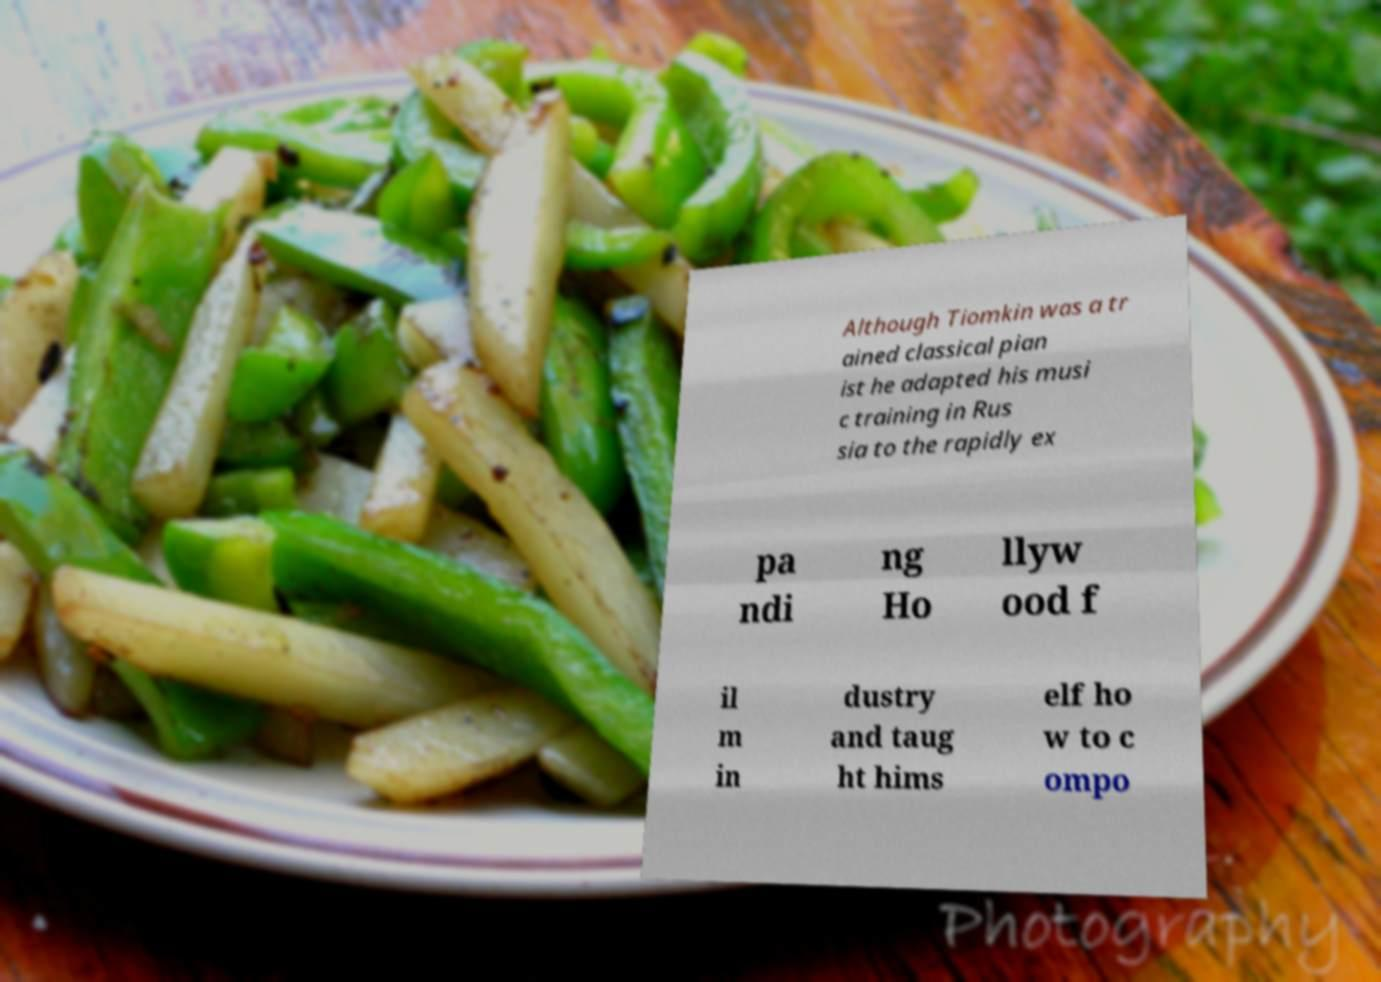Please identify and transcribe the text found in this image. Although Tiomkin was a tr ained classical pian ist he adapted his musi c training in Rus sia to the rapidly ex pa ndi ng Ho llyw ood f il m in dustry and taug ht hims elf ho w to c ompo 